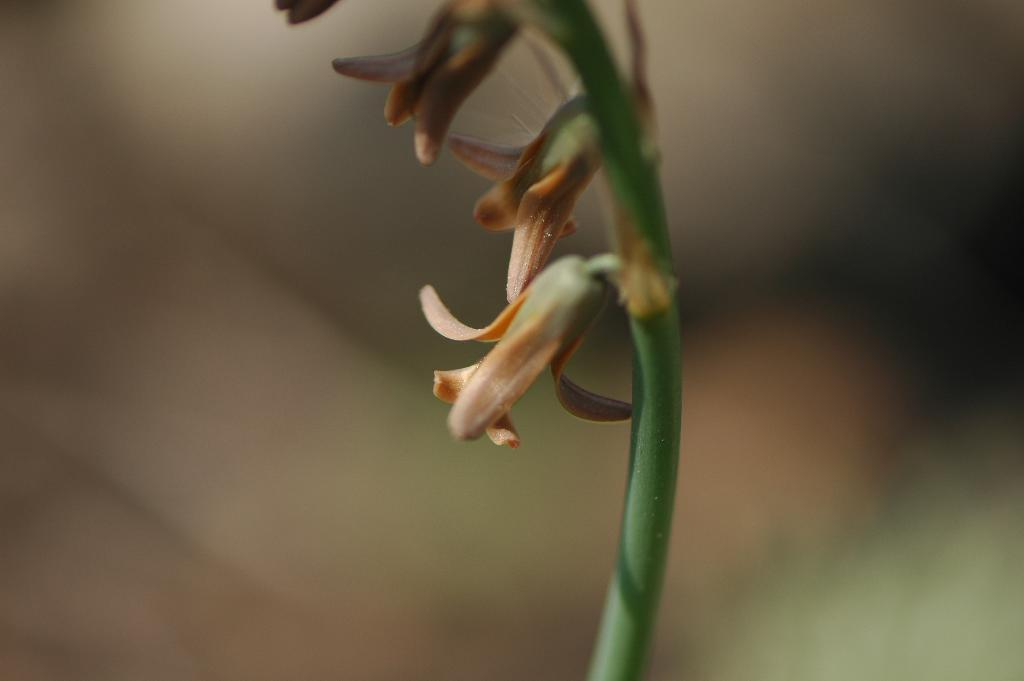What type of plants can be seen in the image? There are flowers in the image. Can you describe any specific part of the flowers? There is a stem in the image. What is the appearance of the background in the image? The background of the image is blurred. What type of expansion can be seen in the image? There is no expansion visible in the image; it features flowers with a stem and a blurred background. 